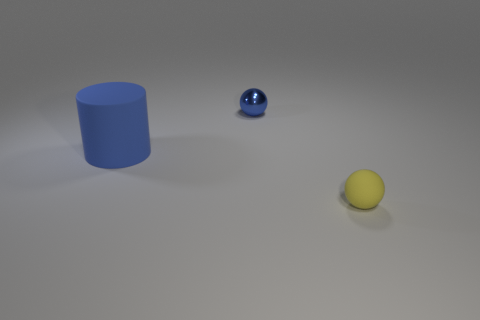How many objects are small things that are behind the matte ball or small blue metallic spheres?
Provide a short and direct response. 1. What size is the sphere that is made of the same material as the cylinder?
Your response must be concise. Small. Does the metal ball have the same size as the blue object in front of the tiny blue sphere?
Offer a terse response. No. The object that is to the left of the yellow rubber thing and on the right side of the blue rubber thing is what color?
Your response must be concise. Blue. How many things are tiny blue metallic objects that are on the right side of the big blue cylinder or blue objects that are on the right side of the large blue matte cylinder?
Your answer should be compact. 1. There is a sphere left of the ball that is in front of the tiny thing on the left side of the yellow sphere; what color is it?
Your response must be concise. Blue. Is there another tiny thing of the same shape as the metallic object?
Keep it short and to the point. Yes. What number of rubber objects are there?
Keep it short and to the point. 2. What is the shape of the tiny rubber thing?
Your answer should be compact. Sphere. What number of shiny balls have the same size as the yellow thing?
Keep it short and to the point. 1. 